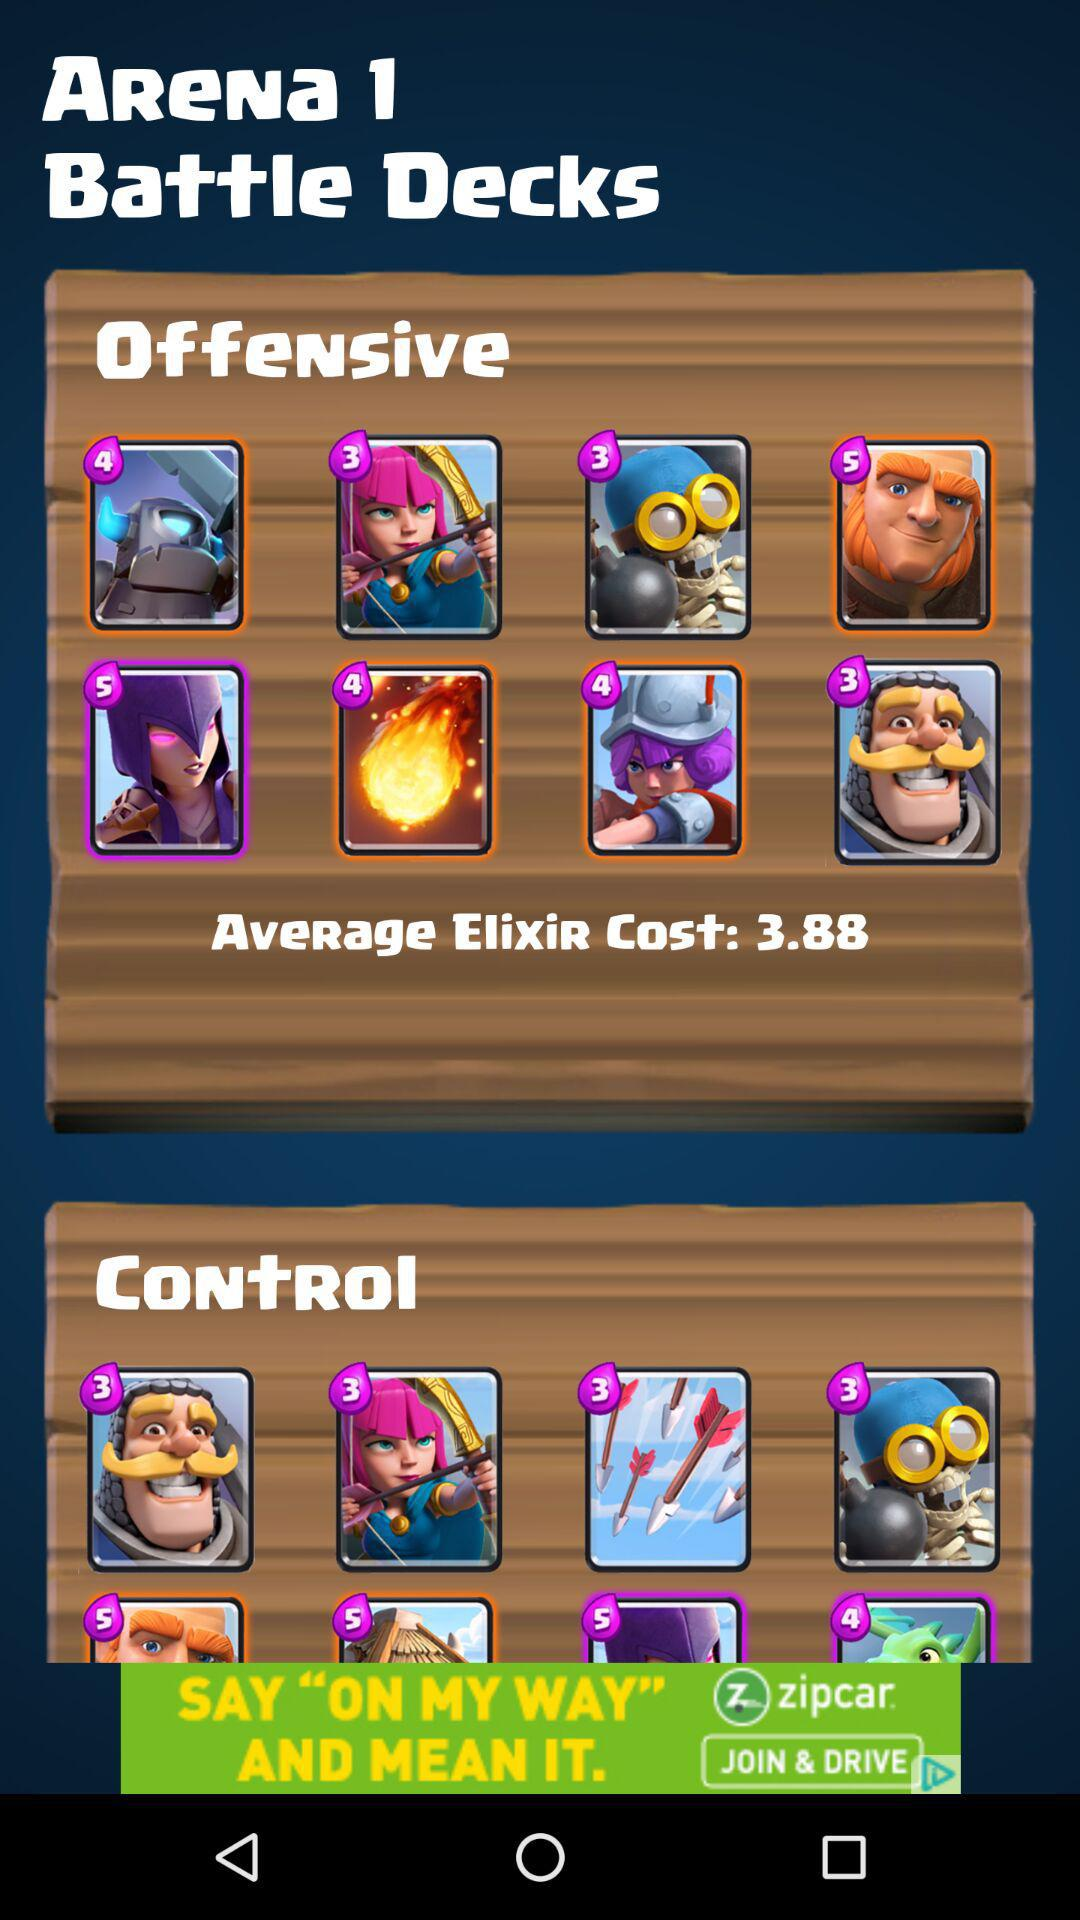What is the name of the application?
When the provided information is insufficient, respond with <no answer>. <no answer> 